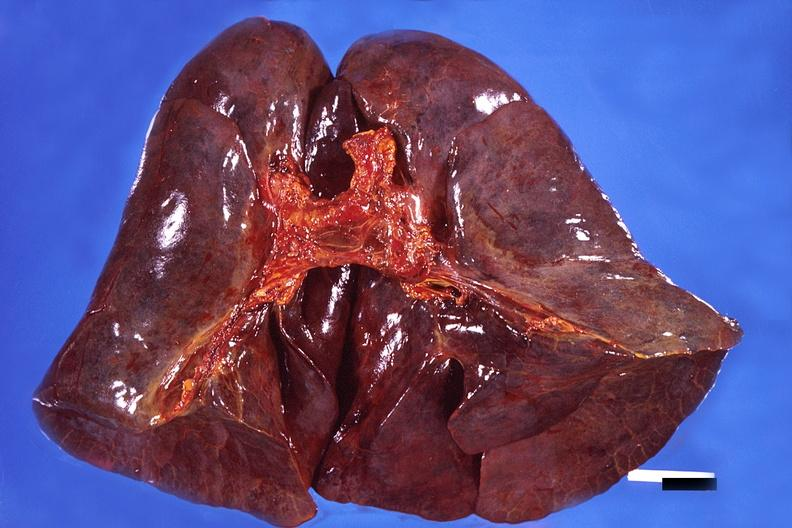what is present?
Answer the question using a single word or phrase. Respiratory 